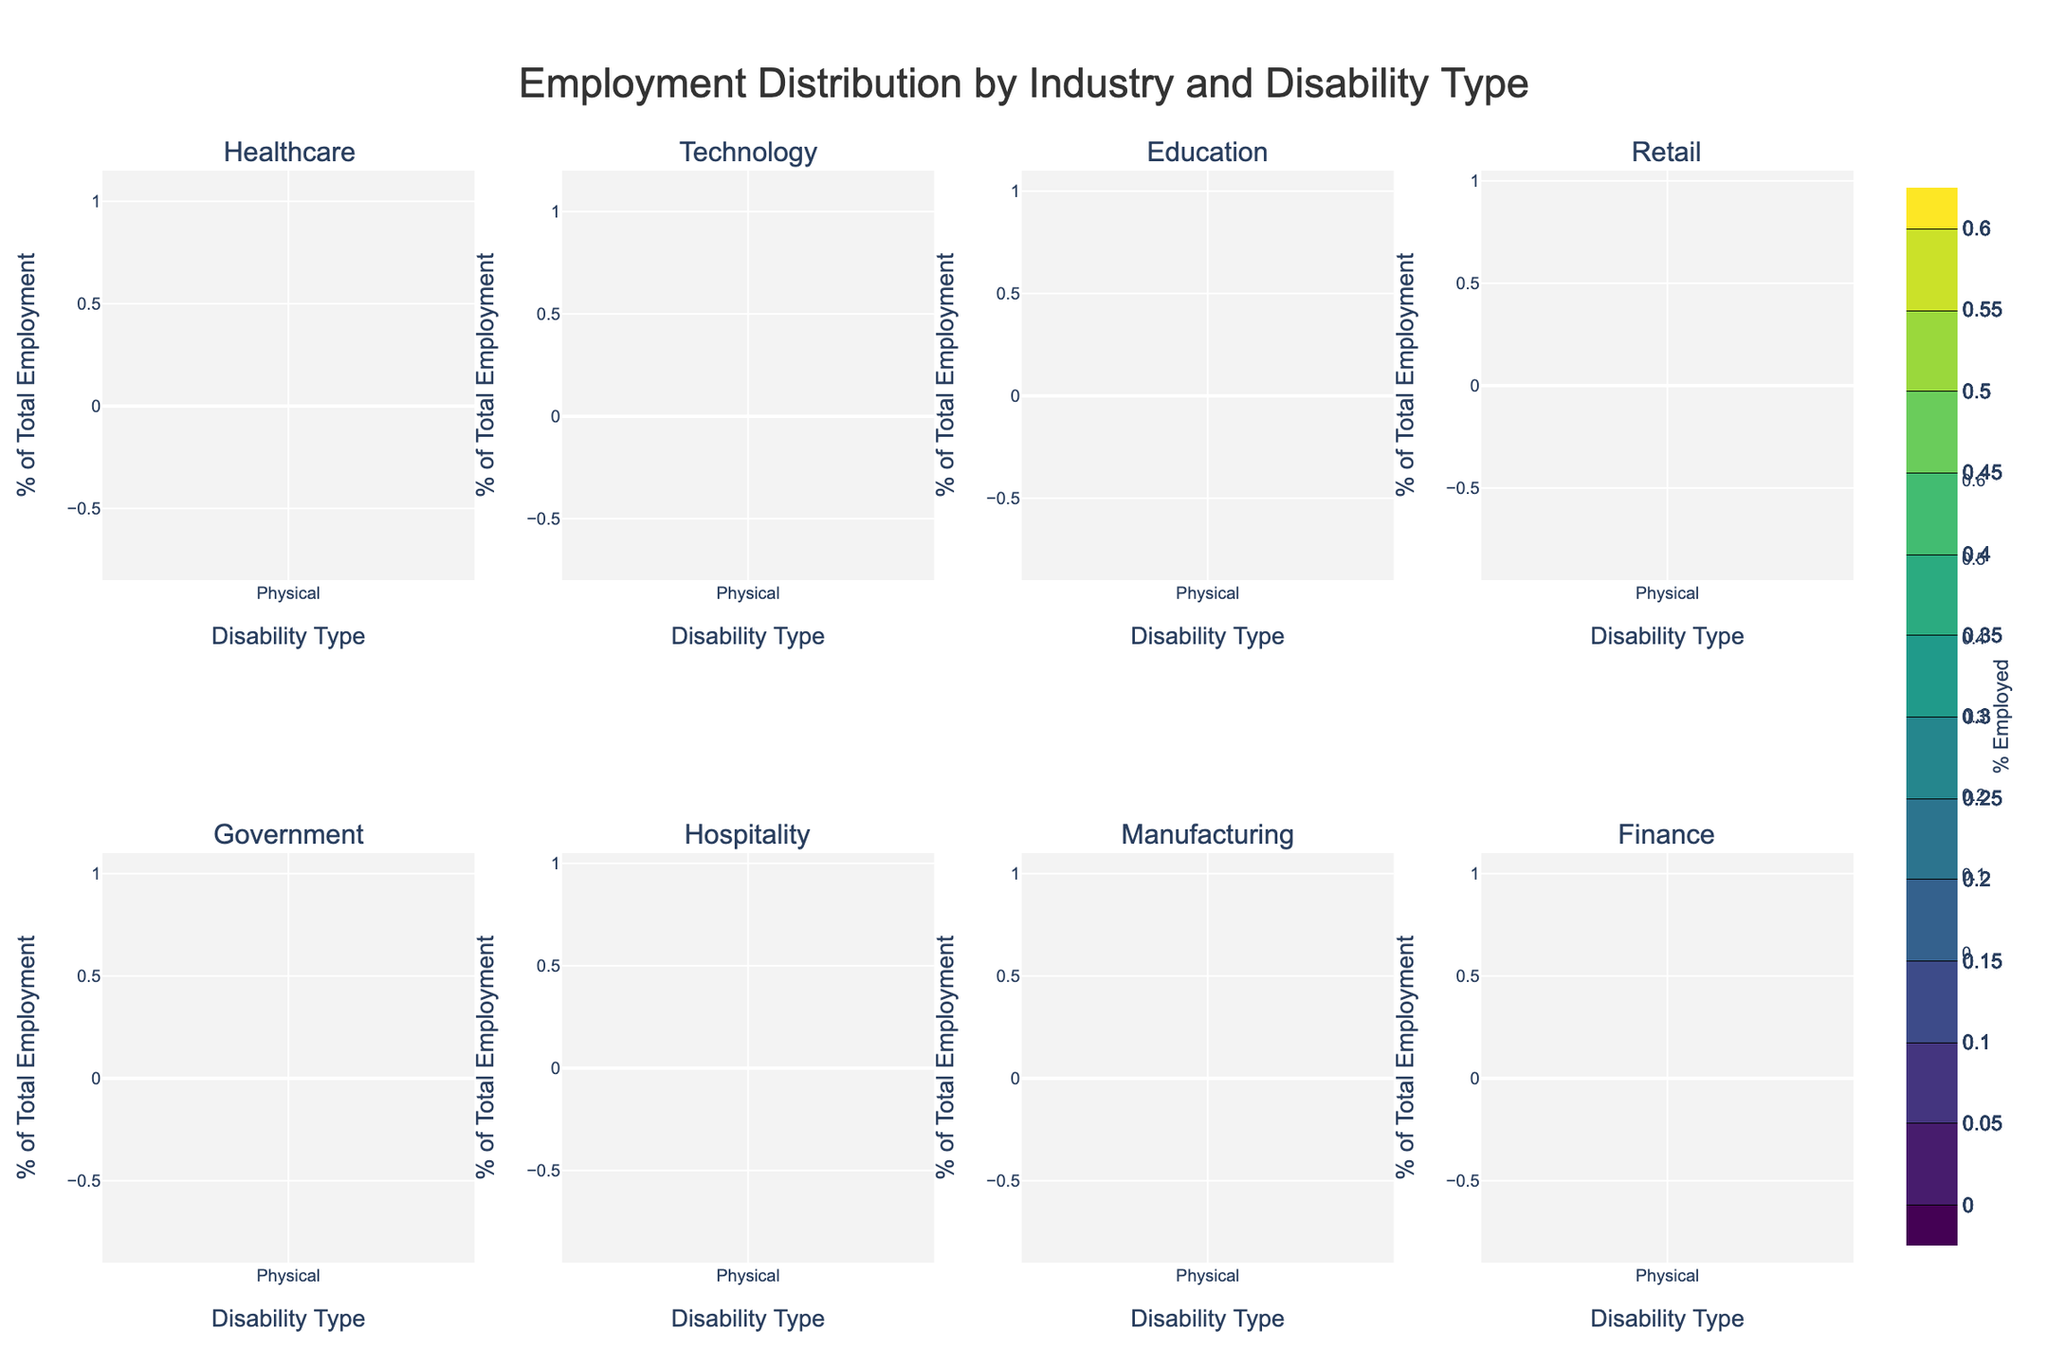What is the title of the figure? The title of the figure is usually placed at the top center of the visual representation and is typically in larger font size to catch attention.
Answer: Employment Distribution by Industry and Disability Type Which disability type has the highest percentage of employment in the Healthcare industry? In the Healthcare subplot, the contour lines with higher values indicate greater percentages. The highest contour peak corresponds to Physical disabilities.
Answer: Physical How does the employment distribution differ between the Technology and Education industries for individuals with Hearing disabilities? For the Technology industry, the peak value for Hearing disabilities is at 0.35, whereas in the Education industry, it peaks at 0.30.
Answer: Technology has a higher employment rate for Hearing disabilities Which industry shows the lowest employment percentage for individuals with Visual disabilities? To find this, we look at all subplots and identify the contour with the lowest peak for Visual disabilities, which is in the Hospitality industry at 0.10.
Answer: Hospitality Compare the employment distribution between Physical and Visual disabilities in the Manufacturing industry. In the Manufacturing subplot, Physical disabilities peak at 0.45 while Visual disabilities peak at 0.15, indicating a higher employment distribution for Physical disabilities.
Answer: Physical has a higher employment rate Which industry has the most balanced employment distribution across all disability types? By analyzing the subplots, industries with peaks closer in value across different disability types show a balanced distribution. The Education industry appears most balanced as its peaks are close (0.25-0.30).
Answer: Education What's the average percentage of employment for individuals with Mental disabilities across all industries? The mental disability employment percentages are 0.15, 0.10, 0.15, 0.10, 0.15, 0.15, 0.10, and 0.15 for the eight industries. Summing these up: 1.15. Dividing by 8 gives the average 1.15/8 = 0.14375.
Answer: 0.14375 In which industry is the employment percentage for Physical disabilities more than twice the employment percentage for Visual disabilities? By comparing the contours, the Retail industry shows a peak of 0.50 for Physical disabilities and 0.15 for Visual disabilities, which is more than twice.
Answer: Retail 